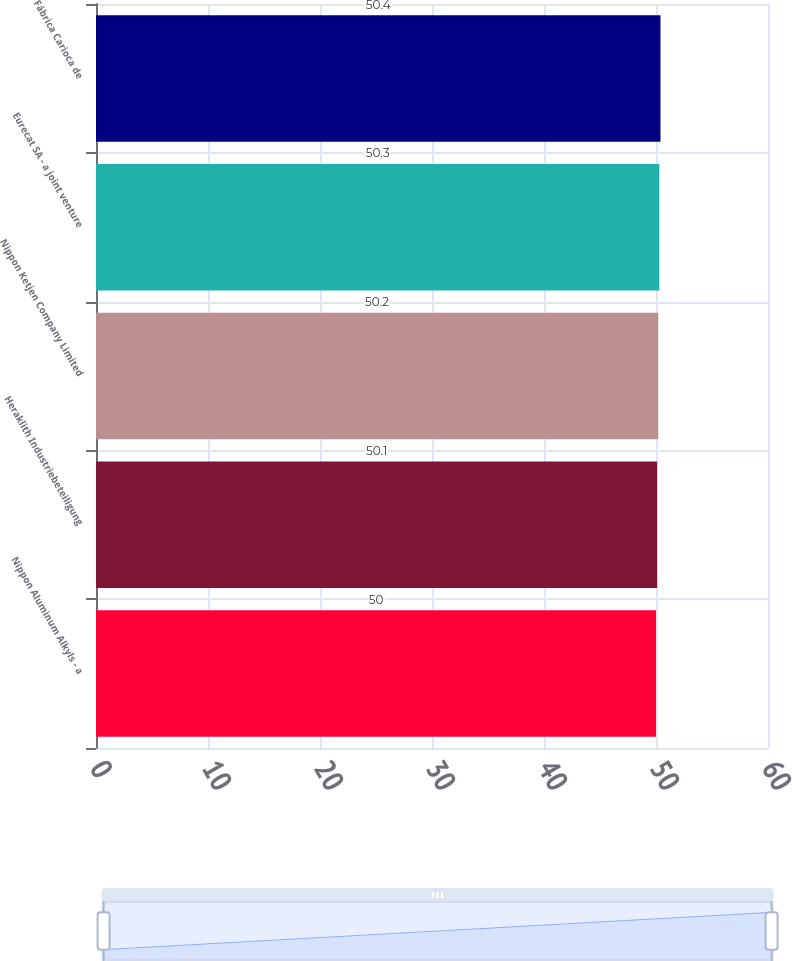Convert chart to OTSL. <chart><loc_0><loc_0><loc_500><loc_500><bar_chart><fcel>Nippon Aluminum Alkyls - a<fcel>Heraklith Industriebeteiligung<fcel>Nippon Ketjen Company Limited<fcel>Eurecat SA - a joint venture<fcel>Fábrica Carioca de<nl><fcel>50<fcel>50.1<fcel>50.2<fcel>50.3<fcel>50.4<nl></chart> 